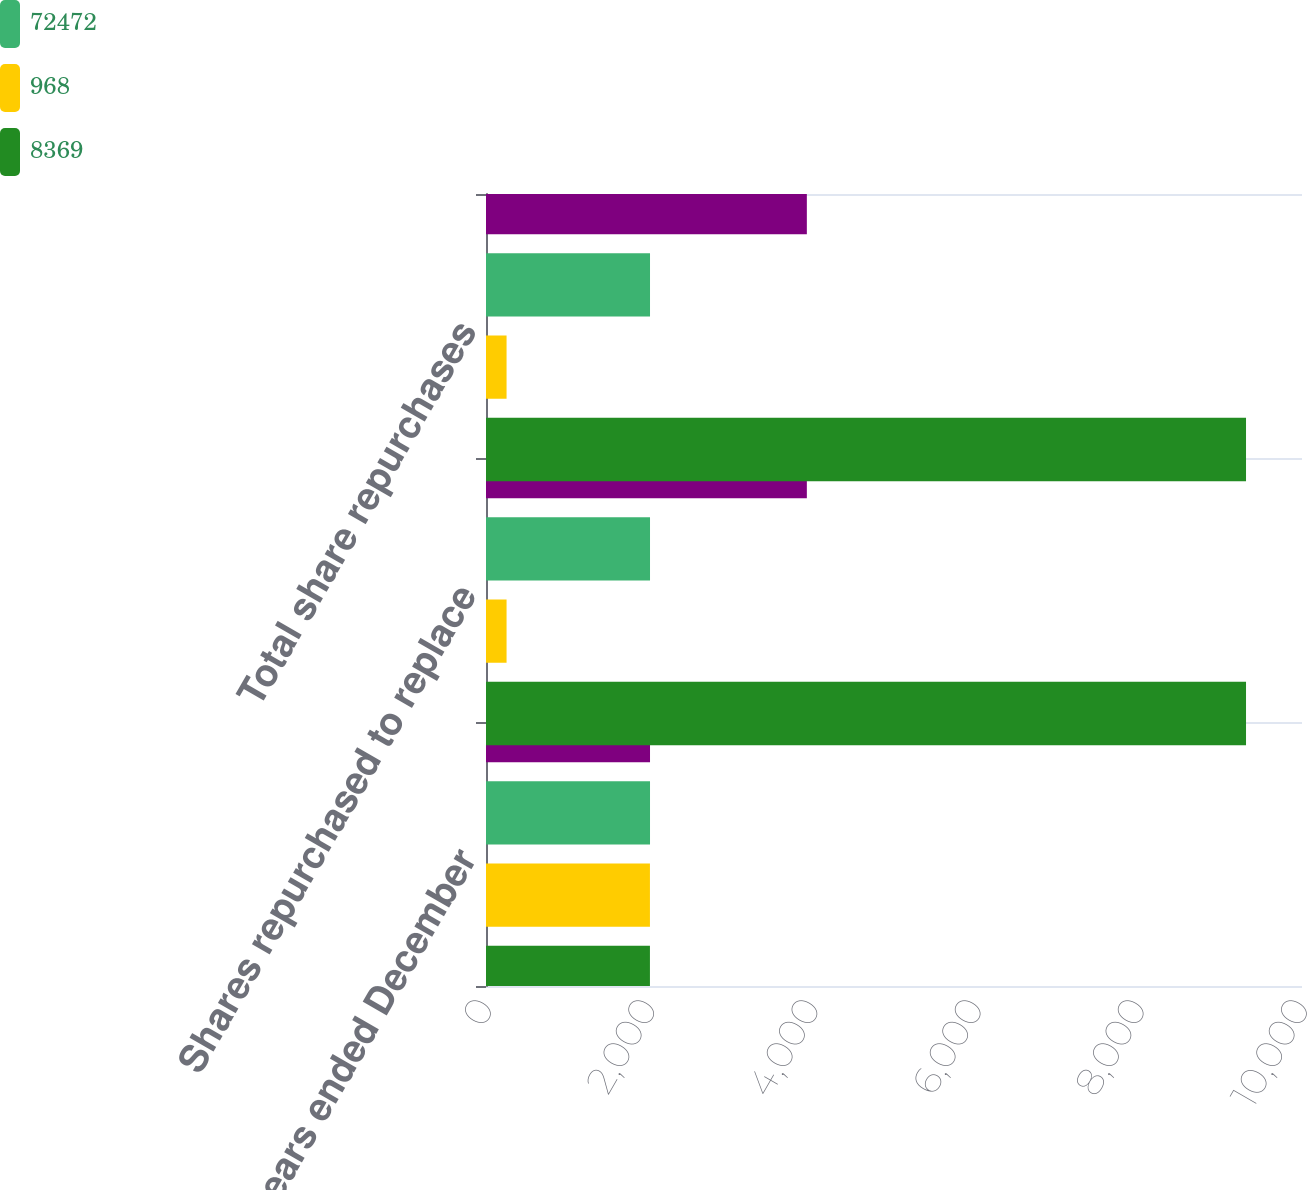Convert chart to OTSL. <chart><loc_0><loc_0><loc_500><loc_500><stacked_bar_chart><ecel><fcel>For the years ended December<fcel>Shares repurchased to replace<fcel>Total share repurchases<nl><fcel>nan<fcel>2010<fcel>3932<fcel>3932<nl><fcel>72472<fcel>2010<fcel>2010<fcel>2010<nl><fcel>968<fcel>2009<fcel>252<fcel>252<nl><fcel>8369<fcel>2009<fcel>9314<fcel>9314<nl></chart> 